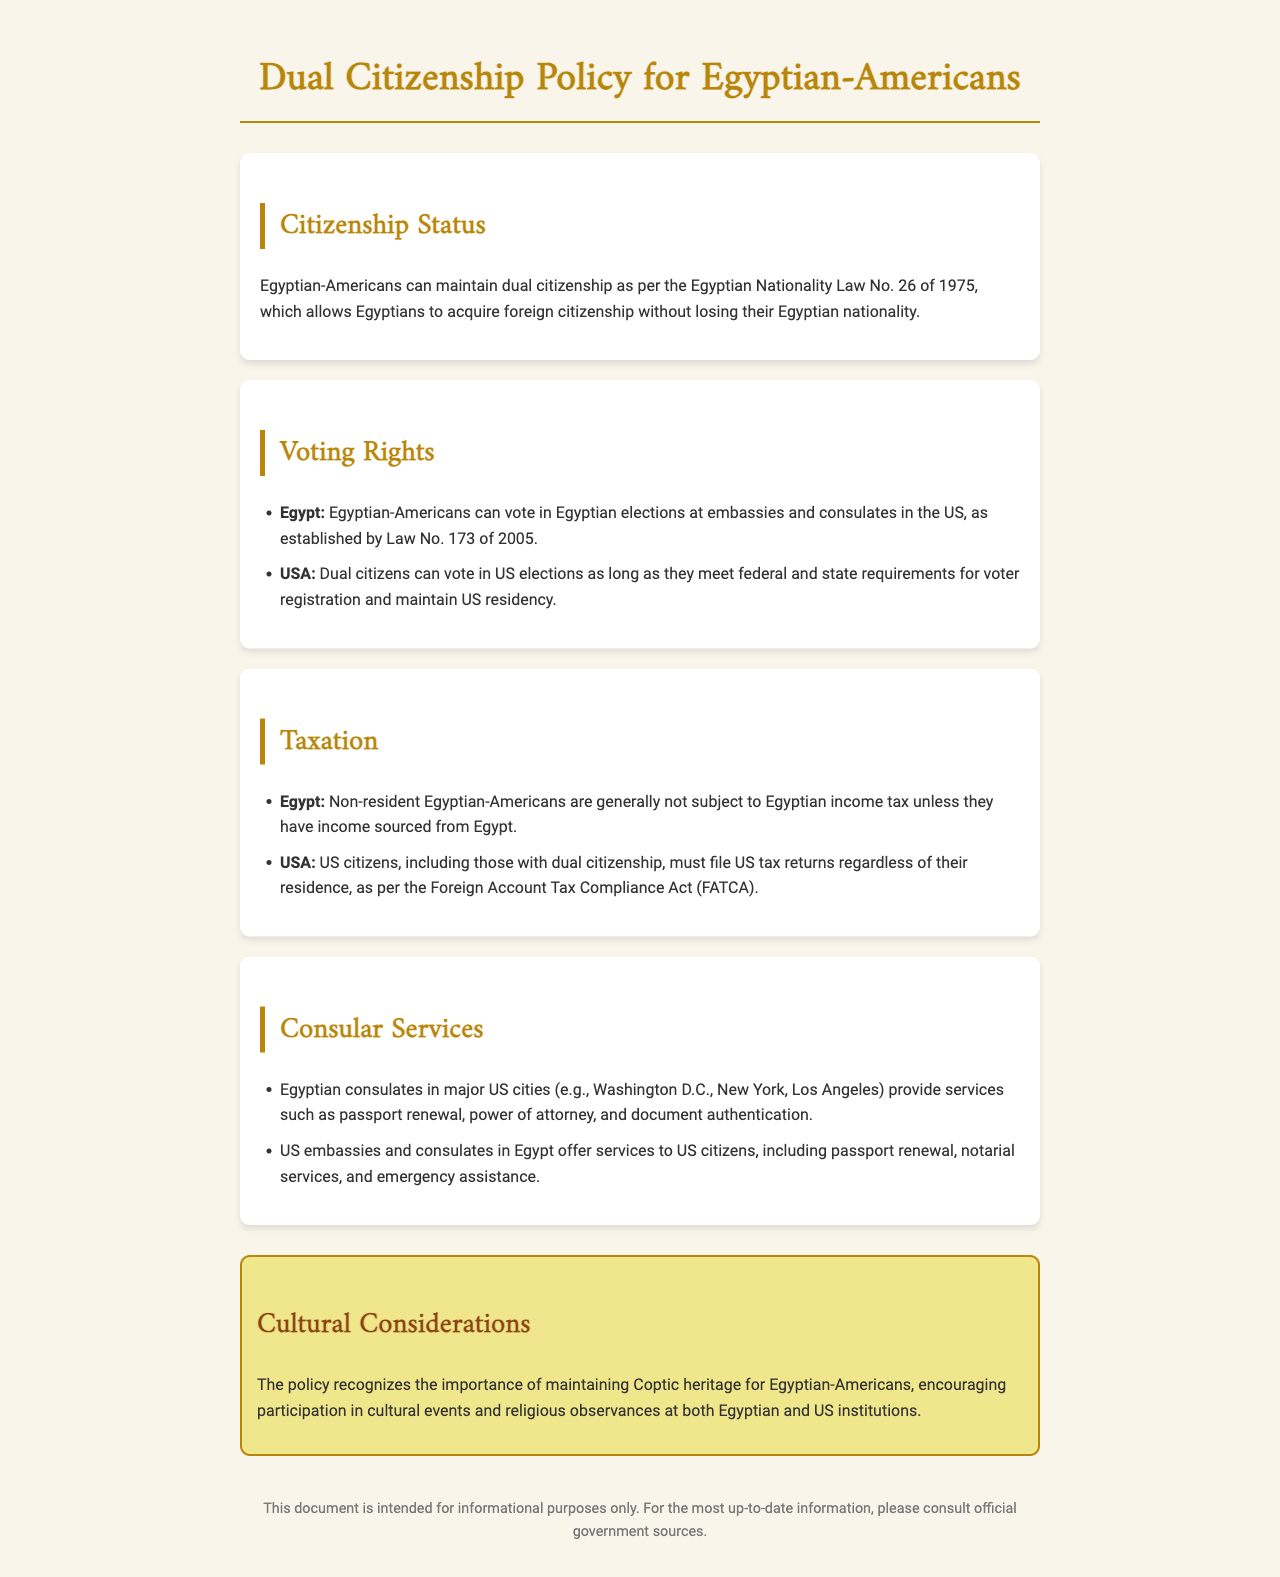What law allows dual citizenship for Egyptians? The law that allows Egyptian-Americans to maintain dual citizenship is the Egyptian Nationality Law No. 26 of 1975.
Answer: Egyptian Nationality Law No. 26 of 1975 Where can Egyptian-Americans vote in Egypt? Egyptian-Americans can vote in Egyptian elections at embassies and consulates in the US as per Law No. 173 of 2005.
Answer: Embassies and consulates in the US Are dual citizens required to file US tax returns? Yes, US citizens, including those with dual citizenship, must file US tax returns as per the Foreign Account Tax Compliance Act (FATCA).
Answer: Yes What services do Egyptian consulates in the US provide? Egyptian consulates in major US cities provide services such as passport renewal, power of attorney, and document authentication.
Answer: Passport renewal, power of attorney, document authentication What tax obligation do non-resident Egyptian-Americans have? Non-resident Egyptian-Americans are generally not subject to Egyptian income tax unless they have income sourced from Egypt.
Answer: Not subject unless income sourced from Egypt How does the policy recognize cultural heritage? The policy encourages participation in cultural events and religious observances at both Egyptian and US institutions.
Answer: Cultural events and religious observances What is the purpose of this document? The document is intended for informational purposes only.
Answer: Informational purposes only 